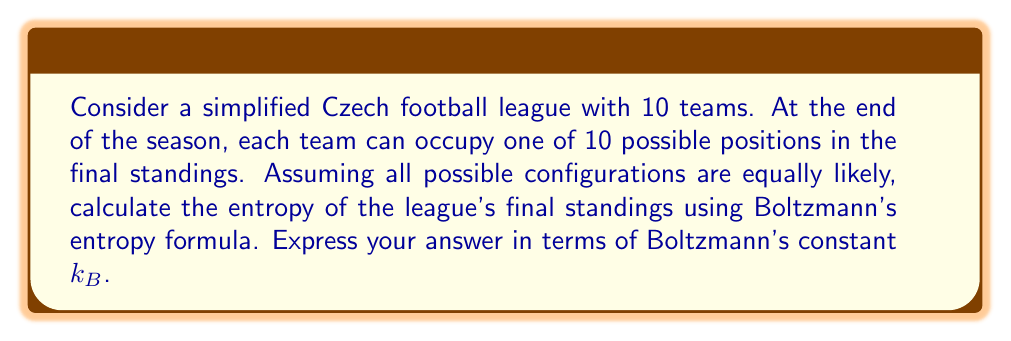Can you solve this math problem? To solve this problem, we'll use Boltzmann's entropy formula and concepts from statistical mechanics:

1) Boltzmann's entropy formula is given by:

   $$S = k_B \ln W$$

   where $S$ is entropy, $k_B$ is Boltzmann's constant, and $W$ is the number of microstates.

2) In this case, each microstate represents a unique configuration of the league standings.

3) To calculate $W$, we need to determine how many ways 10 teams can be arranged in 10 positions:
   
   $$W = 10!$$

4) Substituting this into Boltzmann's formula:

   $$S = k_B \ln(10!)$$

5) We can simplify this using Stirling's approximation for large $n$:

   $$\ln(n!) \approx n \ln(n) - n$$

6) Applying this to our problem:

   $$S \approx k_B (10 \ln(10) - 10)$$

7) Simplifying:

   $$S \approx k_B (23.03 - 10) = 13.03k_B$$

Therefore, the entropy of the league's final standings is approximately $13.03k_B$.
Answer: $13.03k_B$ 